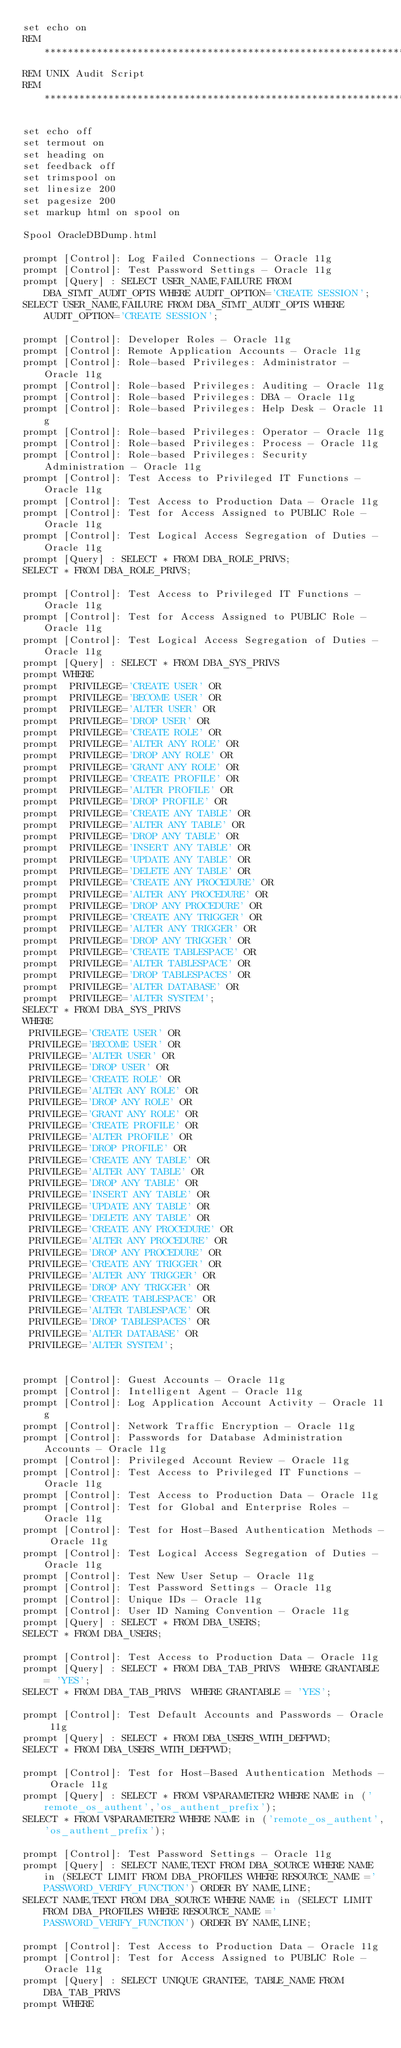Convert code to text. <code><loc_0><loc_0><loc_500><loc_500><_SQL_>set echo on
REM **************************************************************************
REM UNIX Audit Script
REM **************************************************************************

set echo off
set termout on
set heading on
set feedback off
set trimspool on
set linesize 200
set pagesize 200
set markup html on spool on

Spool OracleDBDump.html

prompt [Control]: Log Failed Connections - Oracle 11g
prompt [Control]: Test Password Settings - Oracle 11g
prompt [Query] : SELECT USER_NAME,FAILURE FROM DBA_STMT_AUDIT_OPTS WHERE AUDIT_OPTION='CREATE SESSION';
SELECT USER_NAME,FAILURE FROM DBA_STMT_AUDIT_OPTS WHERE AUDIT_OPTION='CREATE SESSION';

prompt [Control]: Developer Roles - Oracle 11g
prompt [Control]: Remote Application Accounts - Oracle 11g
prompt [Control]: Role-based Privileges: Administrator - Oracle 11g
prompt [Control]: Role-based Privileges: Auditing - Oracle 11g
prompt [Control]: Role-based Privileges: DBA - Oracle 11g
prompt [Control]: Role-based Privileges: Help Desk - Oracle 11g
prompt [Control]: Role-based Privileges: Operator - Oracle 11g
prompt [Control]: Role-based Privileges: Process - Oracle 11g
prompt [Control]: Role-based Privileges: Security Administration - Oracle 11g
prompt [Control]: Test Access to Privileged IT Functions - Oracle 11g
prompt [Control]: Test Access to Production Data - Oracle 11g
prompt [Control]: Test for Access Assigned to PUBLIC Role - Oracle 11g
prompt [Control]: Test Logical Access Segregation of Duties - Oracle 11g
prompt [Query] : SELECT * FROM DBA_ROLE_PRIVS;
SELECT * FROM DBA_ROLE_PRIVS;

prompt [Control]: Test Access to Privileged IT Functions - Oracle 11g
prompt [Control]: Test for Access Assigned to PUBLIC Role - Oracle 11g
prompt [Control]: Test Logical Access Segregation of Duties - Oracle 11g
prompt [Query] : SELECT * FROM DBA_SYS_PRIVS
prompt WHERE 
prompt  PRIVILEGE='CREATE USER' OR
prompt  PRIVILEGE='BECOME USER' OR
prompt  PRIVILEGE='ALTER USER' OR
prompt  PRIVILEGE='DROP USER' OR
prompt  PRIVILEGE='CREATE ROLE' OR
prompt  PRIVILEGE='ALTER ANY ROLE' OR
prompt  PRIVILEGE='DROP ANY ROLE' OR
prompt  PRIVILEGE='GRANT ANY ROLE' OR
prompt  PRIVILEGE='CREATE PROFILE' OR
prompt  PRIVILEGE='ALTER PROFILE' OR
prompt  PRIVILEGE='DROP PROFILE' OR
prompt  PRIVILEGE='CREATE ANY TABLE' OR
prompt  PRIVILEGE='ALTER ANY TABLE' OR
prompt  PRIVILEGE='DROP ANY TABLE' OR
prompt  PRIVILEGE='INSERT ANY TABLE' OR
prompt  PRIVILEGE='UPDATE ANY TABLE' OR
prompt  PRIVILEGE='DELETE ANY TABLE' OR
prompt  PRIVILEGE='CREATE ANY PROCEDURE' OR
prompt  PRIVILEGE='ALTER ANY PROCEDURE' OR
prompt  PRIVILEGE='DROP ANY PROCEDURE' OR
prompt  PRIVILEGE='CREATE ANY TRIGGER' OR
prompt  PRIVILEGE='ALTER ANY TRIGGER' OR
prompt  PRIVILEGE='DROP ANY TRIGGER' OR
prompt  PRIVILEGE='CREATE TABLESPACE' OR
prompt  PRIVILEGE='ALTER TABLESPACE' OR
prompt  PRIVILEGE='DROP TABLESPACES' OR
prompt  PRIVILEGE='ALTER DATABASE' OR
prompt  PRIVILEGE='ALTER SYSTEM';
SELECT * FROM DBA_SYS_PRIVS
WHERE 
 PRIVILEGE='CREATE USER' OR
 PRIVILEGE='BECOME USER' OR
 PRIVILEGE='ALTER USER' OR
 PRIVILEGE='DROP USER' OR
 PRIVILEGE='CREATE ROLE' OR
 PRIVILEGE='ALTER ANY ROLE' OR
 PRIVILEGE='DROP ANY ROLE' OR
 PRIVILEGE='GRANT ANY ROLE' OR
 PRIVILEGE='CREATE PROFILE' OR
 PRIVILEGE='ALTER PROFILE' OR
 PRIVILEGE='DROP PROFILE' OR
 PRIVILEGE='CREATE ANY TABLE' OR
 PRIVILEGE='ALTER ANY TABLE' OR
 PRIVILEGE='DROP ANY TABLE' OR
 PRIVILEGE='INSERT ANY TABLE' OR
 PRIVILEGE='UPDATE ANY TABLE' OR
 PRIVILEGE='DELETE ANY TABLE' OR
 PRIVILEGE='CREATE ANY PROCEDURE' OR
 PRIVILEGE='ALTER ANY PROCEDURE' OR
 PRIVILEGE='DROP ANY PROCEDURE' OR
 PRIVILEGE='CREATE ANY TRIGGER' OR
 PRIVILEGE='ALTER ANY TRIGGER' OR
 PRIVILEGE='DROP ANY TRIGGER' OR
 PRIVILEGE='CREATE TABLESPACE' OR
 PRIVILEGE='ALTER TABLESPACE' OR
 PRIVILEGE='DROP TABLESPACES' OR
 PRIVILEGE='ALTER DATABASE' OR
 PRIVILEGE='ALTER SYSTEM';


prompt [Control]: Guest Accounts - Oracle 11g
prompt [Control]: Intelligent Agent - Oracle 11g
prompt [Control]: Log Application Account Activity - Oracle 11g
prompt [Control]: Network Traffic Encryption - Oracle 11g
prompt [Control]: Passwords for Database Administration Accounts - Oracle 11g
prompt [Control]: Privileged Account Review - Oracle 11g
prompt [Control]: Test Access to Privileged IT Functions - Oracle 11g
prompt [Control]: Test Access to Production Data - Oracle 11g
prompt [Control]: Test for Global and Enterprise Roles - Oracle 11g
prompt [Control]: Test for Host-Based Authentication Methods - Oracle 11g
prompt [Control]: Test Logical Access Segregation of Duties - Oracle 11g
prompt [Control]: Test New User Setup - Oracle 11g
prompt [Control]: Test Password Settings - Oracle 11g
prompt [Control]: Unique IDs - Oracle 11g
prompt [Control]: User ID Naming Convention - Oracle 11g
prompt [Query] : SELECT * FROM DBA_USERS;
SELECT * FROM DBA_USERS;

prompt [Control]: Test Access to Production Data - Oracle 11g
prompt [Query] : SELECT * FROM DBA_TAB_PRIVS  WHERE GRANTABLE = 'YES';
SELECT * FROM DBA_TAB_PRIVS  WHERE GRANTABLE = 'YES';

prompt [Control]: Test Default Accounts and Passwords - Oracle 11g
prompt [Query] : SELECT * FROM DBA_USERS_WITH_DEFPWD;
SELECT * FROM DBA_USERS_WITH_DEFPWD;

prompt [Control]: Test for Host-Based Authentication Methods - Oracle 11g
prompt [Query] : SELECT * FROM V$PARAMETER2 WHERE NAME in ('remote_os_authent','os_authent_prefix');
SELECT * FROM V$PARAMETER2 WHERE NAME in ('remote_os_authent','os_authent_prefix');

prompt [Control]: Test Password Settings - Oracle 11g
prompt [Query] : SELECT NAME,TEXT FROM DBA_SOURCE WHERE NAME in (SELECT LIMIT FROM DBA_PROFILES WHERE RESOURCE_NAME ='PASSWORD_VERIFY_FUNCTION') ORDER BY NAME,LINE;
SELECT NAME,TEXT FROM DBA_SOURCE WHERE NAME in (SELECT LIMIT FROM DBA_PROFILES WHERE RESOURCE_NAME ='PASSWORD_VERIFY_FUNCTION') ORDER BY NAME,LINE;

prompt [Control]: Test Access to Production Data - Oracle 11g
prompt [Control]: Test for Access Assigned to PUBLIC Role - Oracle 11g
prompt [Query] : SELECT UNIQUE GRANTEE, TABLE_NAME FROM DBA_TAB_PRIVS
prompt WHERE</code> 